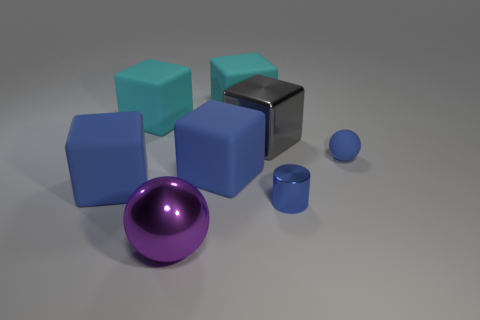Subtract all gray blocks. How many blocks are left? 4 Subtract all gray blocks. How many blocks are left? 4 Add 2 blue blocks. How many objects exist? 10 Subtract all brown cubes. Subtract all purple balls. How many cubes are left? 5 Subtract all blocks. How many objects are left? 3 Subtract 0 red cubes. How many objects are left? 8 Subtract all large blue things. Subtract all cylinders. How many objects are left? 5 Add 2 big gray metallic cubes. How many big gray metallic cubes are left? 3 Add 6 large blue rubber things. How many large blue rubber things exist? 8 